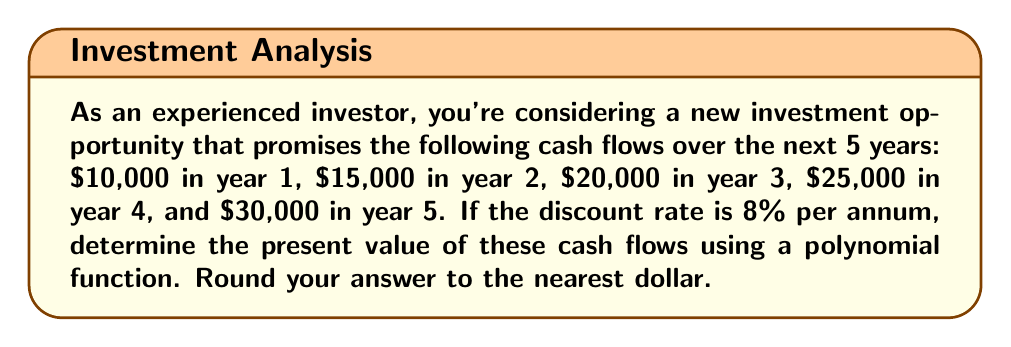Give your solution to this math problem. To solve this problem, we'll follow these steps:

1) First, let's define our polynomial function for the present value:

   $$PV = \frac{C_1}{(1+r)^1} + \frac{C_2}{(1+r)^2} + \frac{C_3}{(1+r)^3} + \frac{C_4}{(1+r)^4} + \frac{C_5}{(1+r)^5}$$

   Where $C_n$ is the cash flow in year n, and r is the discount rate.

2) Now, let's substitute our values:
   $C_1 = 10000$, $C_2 = 15000$, $C_3 = 20000$, $C_4 = 25000$, $C_5 = 30000$
   $r = 0.08$ (8% expressed as a decimal)

3) Let's calculate each term:

   $$\frac{10000}{(1+0.08)^1} = \frac{10000}{1.08} = 9259.26$$
   $$\frac{15000}{(1+0.08)^2} = \frac{15000}{1.1664} = 12859.91$$
   $$\frac{20000}{(1+0.08)^3} = \frac{20000}{1.259712} = 15876.42$$
   $$\frac{25000}{(1+0.08)^4} = \frac{25000}{1.36048896} = 18375.86$$
   $$\frac{30000}{(1+0.08)^5} = \frac{30000}{1.469328077} = 20417.94$$

4) Now, we sum all these terms:

   $$PV = 9259.26 + 12859.91 + 15876.42 + 18375.86 + 20417.94 = 76789.39$$

5) Rounding to the nearest dollar:

   $$PV ≈ 76789$$

Therefore, the present value of the future cash flows is $76,789.
Answer: $76,789 